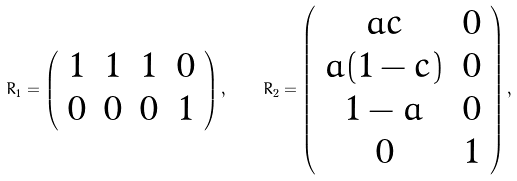<formula> <loc_0><loc_0><loc_500><loc_500>R _ { 1 } = \left ( \begin{array} { c c c c } 1 & 1 & 1 & 0 \\ 0 & 0 & 0 & 1 \end{array} \right ) , \quad R _ { 2 } = \left ( \begin{array} { c c } a c & 0 \\ a ( 1 - c ) & 0 \\ 1 - a & 0 \\ 0 & 1 \end{array} \right ) ,</formula> 